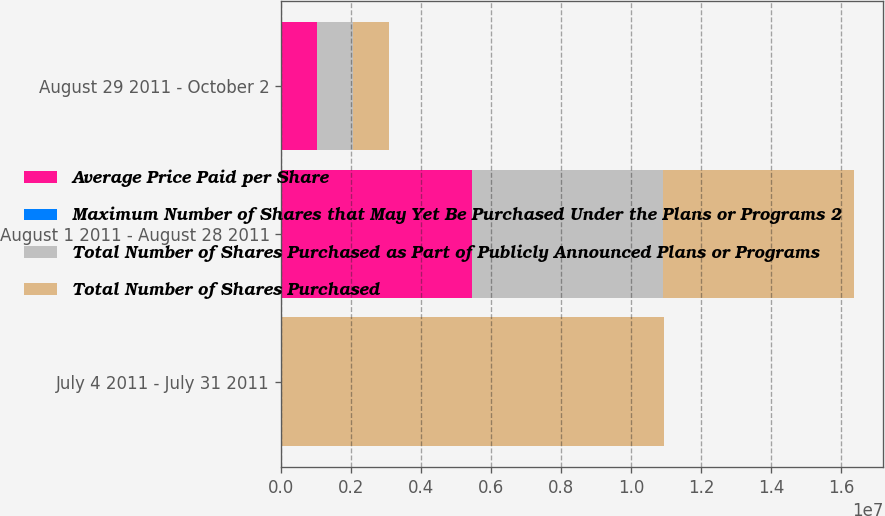Convert chart to OTSL. <chart><loc_0><loc_0><loc_500><loc_500><stacked_bar_chart><ecel><fcel>July 4 2011 - July 31 2011<fcel>August 1 2011 - August 28 2011<fcel>August 29 2011 - October 2<nl><fcel>Average Price Paid per Share<fcel>0<fcel>5.4546e+06<fcel>1.0286e+06<nl><fcel>Maximum Number of Shares that May Yet Be Purchased Under the Plans or Programs 2<fcel>0<fcel>35.86<fcel>37.41<nl><fcel>Total Number of Shares Purchased as Part of Publicly Announced Plans or Programs<fcel>0<fcel>5.4546e+06<fcel>1.0286e+06<nl><fcel>Total Number of Shares Purchased<fcel>1.09295e+07<fcel>5.47486e+06<fcel>1.0286e+06<nl></chart> 